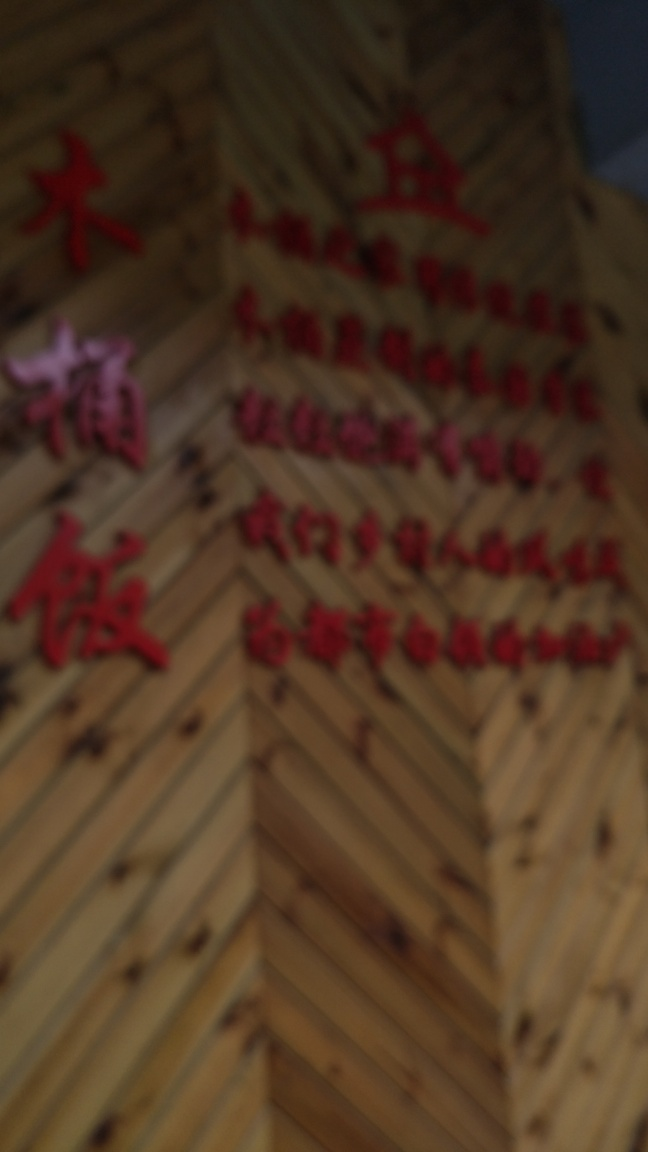Are there any quality issues with this image? Yes, the image is blurry which affects the visibility of details such as text and objects. The lack of focus prevents clear comprehension of the content, and the image is not suitable for purposes that require fine detail or legibility. 